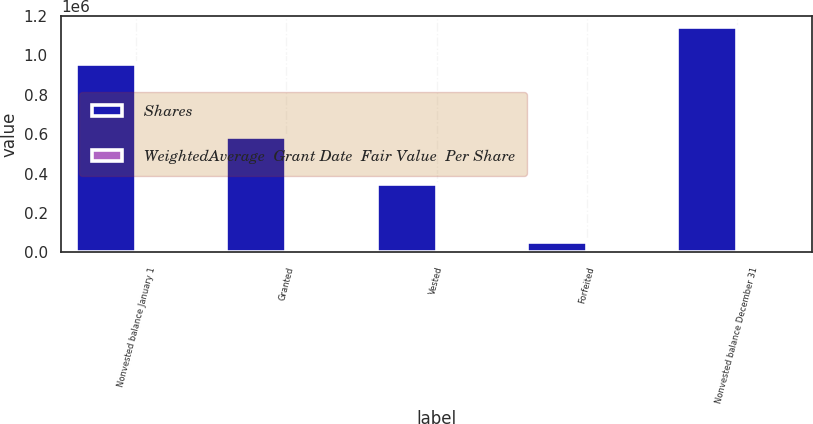<chart> <loc_0><loc_0><loc_500><loc_500><stacked_bar_chart><ecel><fcel>Nonvested balance January 1<fcel>Granted<fcel>Vested<fcel>Forfeited<fcel>Nonvested balance December 31<nl><fcel>Shares<fcel>956697<fcel>586695<fcel>345695<fcel>54415<fcel>1.14328e+06<nl><fcel>WeightedAverage  Grant Date  Fair Value  Per Share<fcel>57.51<fcel>51.5<fcel>53.5<fcel>58.97<fcel>55.55<nl></chart> 